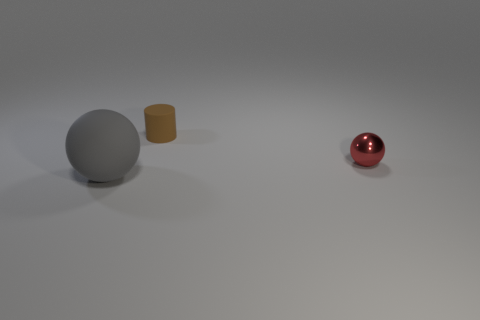Add 1 tiny red balls. How many objects exist? 4 Subtract all spheres. How many objects are left? 1 Add 2 tiny brown matte cylinders. How many tiny brown matte cylinders exist? 3 Subtract 0 red cylinders. How many objects are left? 3 Subtract all yellow blocks. Subtract all large matte spheres. How many objects are left? 2 Add 3 red spheres. How many red spheres are left? 4 